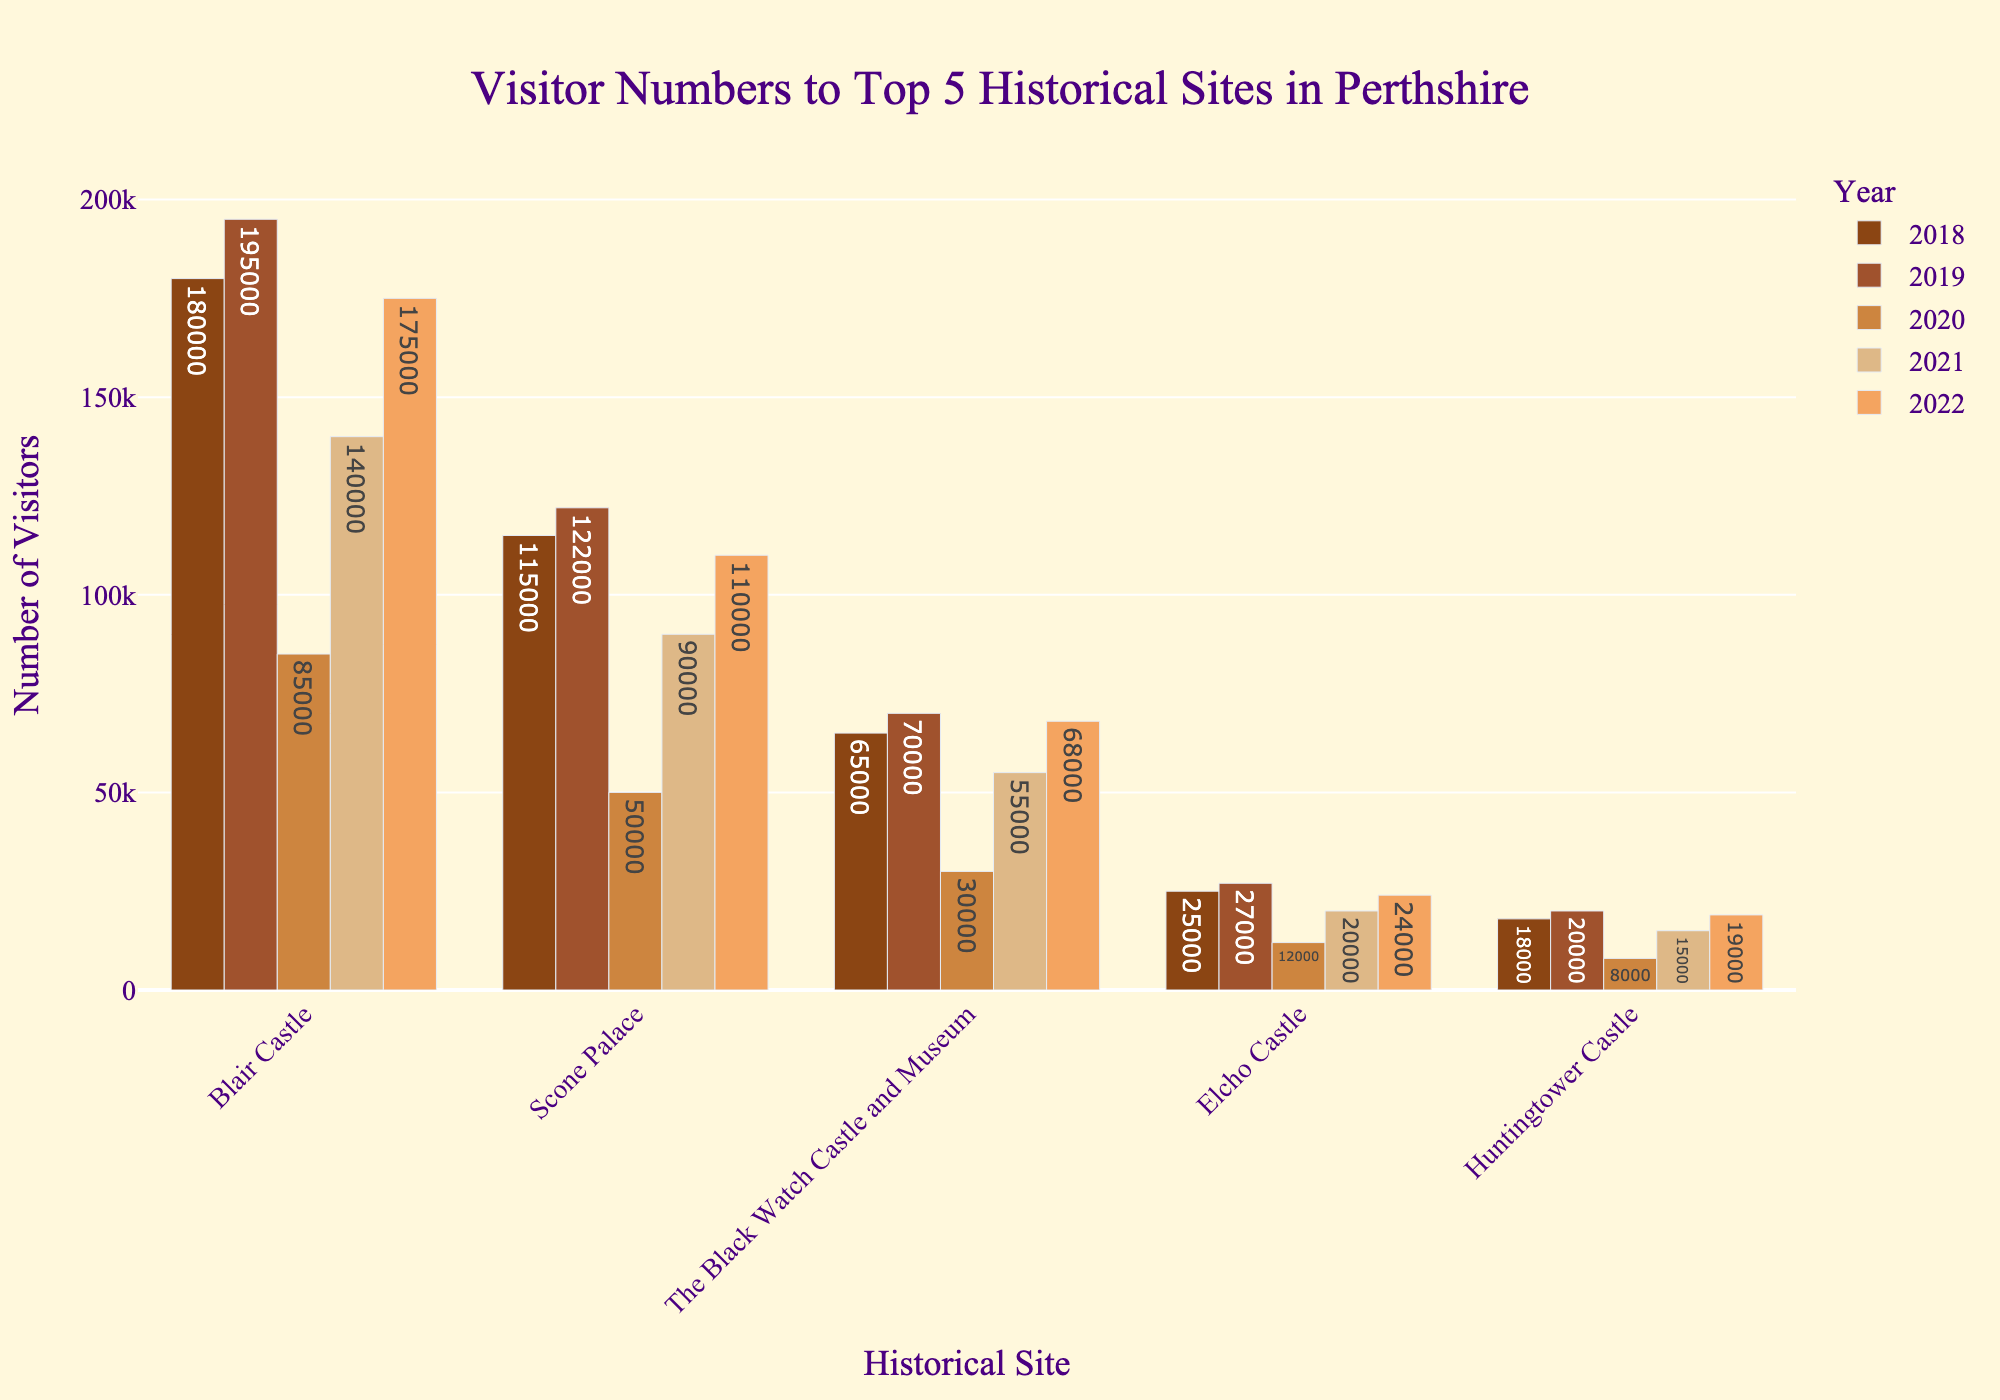Which historical site had the highest number of visitors in 2022? The height of the bars represents the number of visitors. According to the bar representing 2022, Blair Castle had the highest number of visitors among the historical sites in Perthshire.
Answer: Blair Castle How did the visitor numbers to Scone Palace change from 2018 to 2022? First, find the heights of the bars for Scone Palace in each year. The visitor numbers went from 115,000 in 2018, slightly increased to 122,000 in 2019, dropped to 50,000 in 2020, then recovered to 90,000 in 2021, and further increased to 110,000 in 2022. This shows a decline during 2020 and 2021, likely due to the COVID-19 pandemic, followed by a recovery in 2022.
Answer: Increased by 2,000 Which historical site had the fewest visitors in 2020, and how many visitors were there? The height of the bars for 2020 shows that Huntingtower Castle had the shortest bar, indicating the fewest visitors in 2020, with 8,000 visitors.
Answer: Huntingtower Castle, 8,000 What is the average number of visitors to Blair Castle over the 5 years? Add the visitor numbers for Blair Castle over the five years: 180,000 (2018) + 195,000 (2019) + 85,000 (2020) + 140,000 (2021) + 175,000 (2022). The sum is 775,000. Dividing by 5 gives an average.
Answer: 155,000 Compare the visitor numbers of Elcho Castle and Huntingtower Castle in 2021. Which one had more visitors? By how much? Look at the heights of the bars for 2021. Elcho Castle had 20,000 visitors, and Huntingtower Castle had 15,000 visitors. To find the difference, subtract the values: 20,000 - 15,000.
Answer: Elcho Castle, 5,000 What is the total number of visitors for The Black Watch Castle and Museum across all years? Sum the visitor numbers for The Black Watch Castle and Museum from 2018 to 2022: 65,000 + 70,000 + 30,000 + 55,000 + 68,000. The total is 288,000.
Answer: 288,000 Did any historical site have a year-on-year increase in visitor numbers from 2020 to 2021? Compare the heights of the bars for each historical site from 2020 to 2021. For Blair Castle, Scone Palace, The Black Watch Castle and Museum, Elcho Castle, and Huntingtower Castle, all the bars are taller in 2021 than in 2020. Thus, all sites had an increase in visitor numbers from 2020 to 2021.
Answer: All sites Which year showed the lowest overall visitor numbers across all historical sites, and what could be a possible reason? Evaluate the length of the bars for each year and observe that 2020 has the shortest bars collectively. This indicates the lowest overall visitor numbers across all historical sites, likely due to the COVID-19 pandemic restrictions.
Answer: 2020, COVID-19 pandemic How did the visitor numbers at The Black Watch Castle and Museum change from 2018 to 2019? Look at the height of the bars for The Black Watch Castle and Museum for 2018 and 2019. The visitor numbers increased from 65,000 in 2018 to 70,000 in 2019.
Answer: Increased by 5,000 